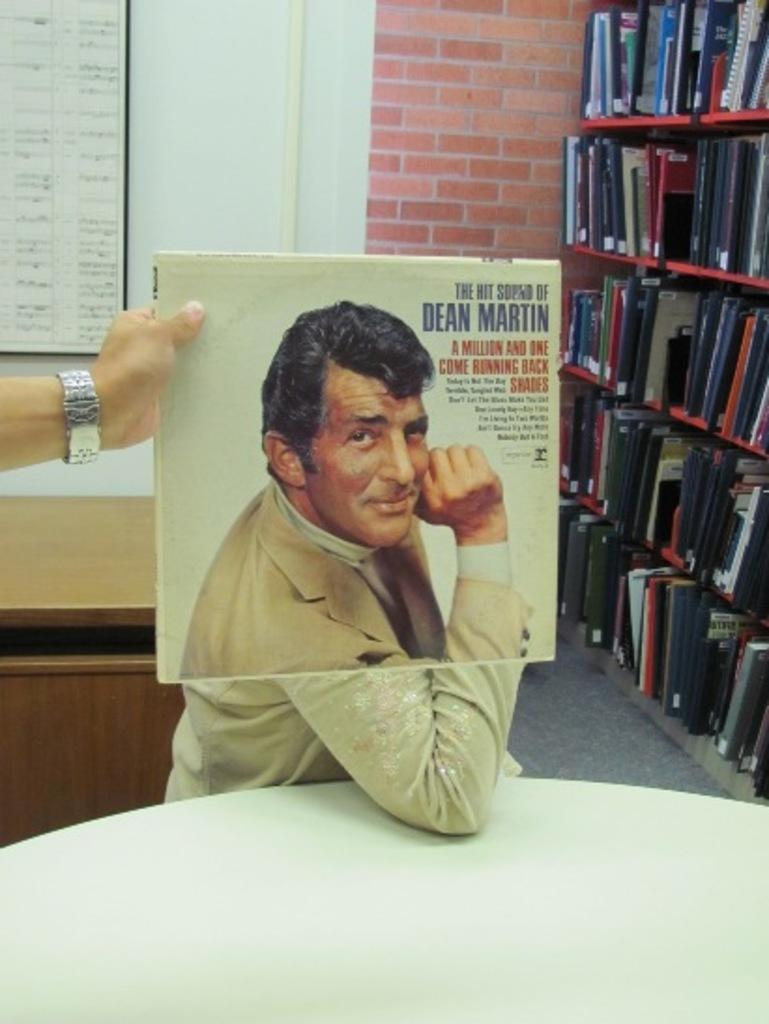<image>
Create a compact narrative representing the image presented. An album of Dean Martin is held in front of a person's face. 